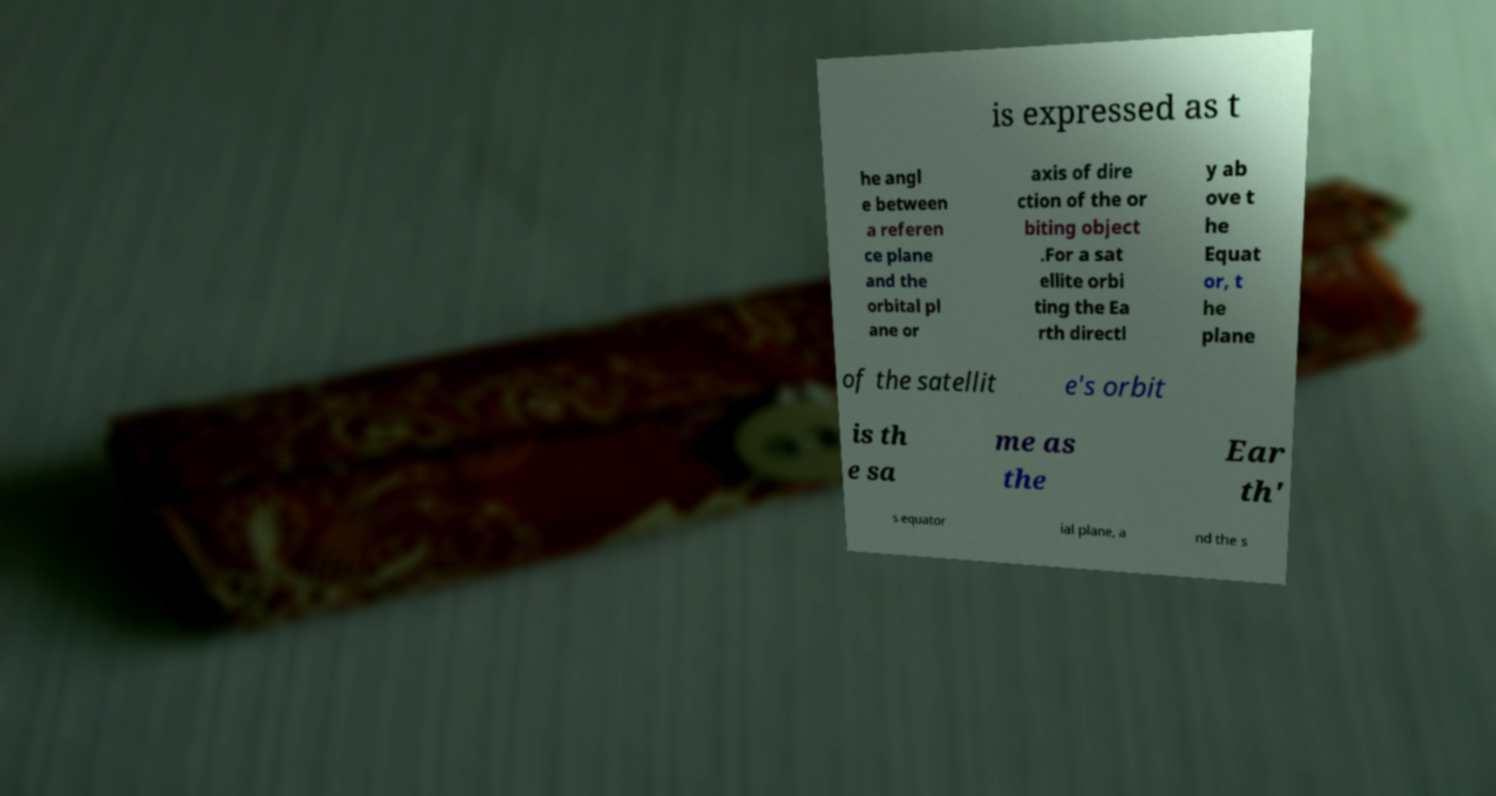Can you accurately transcribe the text from the provided image for me? is expressed as t he angl e between a referen ce plane and the orbital pl ane or axis of dire ction of the or biting object .For a sat ellite orbi ting the Ea rth directl y ab ove t he Equat or, t he plane of the satellit e's orbit is th e sa me as the Ear th' s equator ial plane, a nd the s 